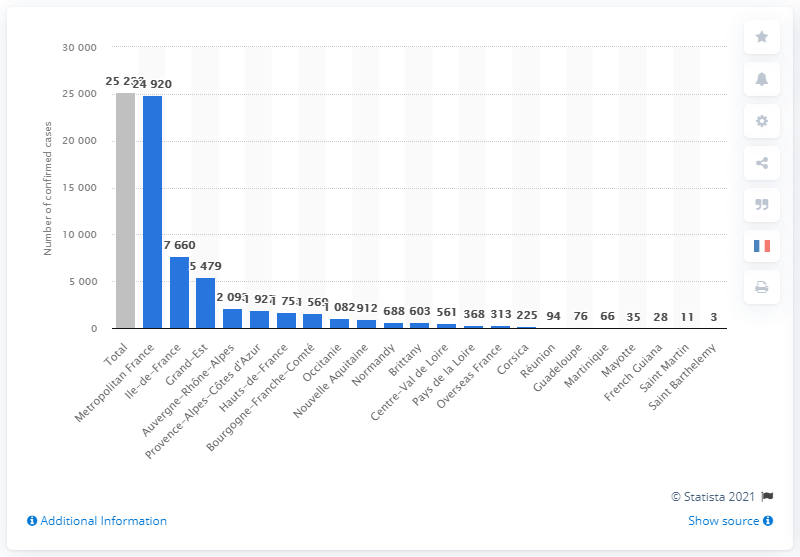Draw attention to some important aspects in this diagram. According to the latest data, a total of 313 cases of COVID-19 have been registered in the overseas territories as of February 11, 2023. 